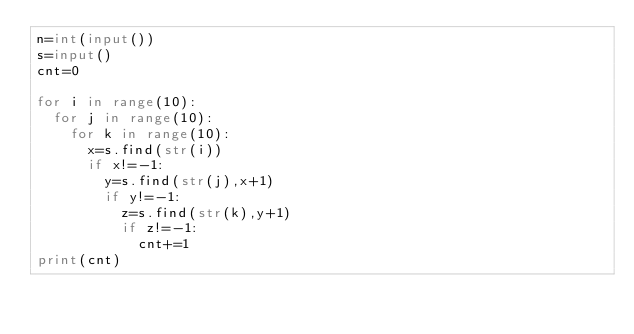<code> <loc_0><loc_0><loc_500><loc_500><_Python_>n=int(input())
s=input()
cnt=0

for i in range(10):
  for j in range(10):
    for k in range(10):
      x=s.find(str(i))
      if x!=-1:
        y=s.find(str(j),x+1)
        if y!=-1:
          z=s.find(str(k),y+1)
          if z!=-1:
            cnt+=1
print(cnt)</code> 